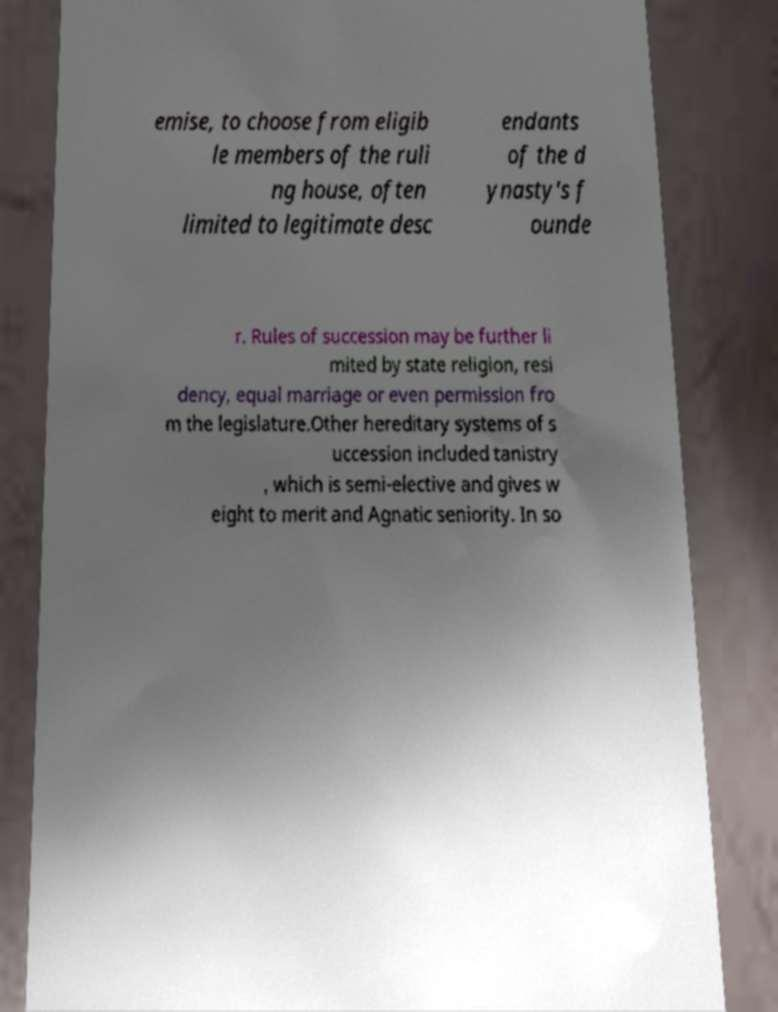Could you extract and type out the text from this image? emise, to choose from eligib le members of the ruli ng house, often limited to legitimate desc endants of the d ynasty's f ounde r. Rules of succession may be further li mited by state religion, resi dency, equal marriage or even permission fro m the legislature.Other hereditary systems of s uccession included tanistry , which is semi-elective and gives w eight to merit and Agnatic seniority. In so 